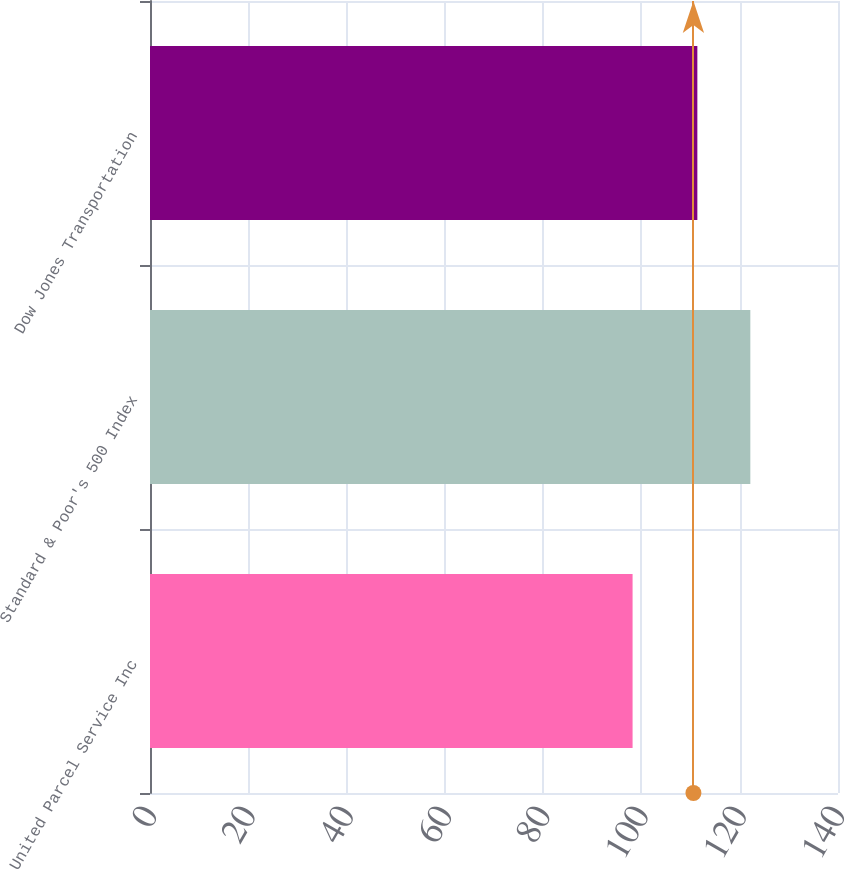Convert chart. <chart><loc_0><loc_0><loc_500><loc_500><bar_chart><fcel>United Parcel Service Inc<fcel>Standard & Poor's 500 Index<fcel>Dow Jones Transportation<nl><fcel>98.2<fcel>122.16<fcel>111.38<nl></chart> 